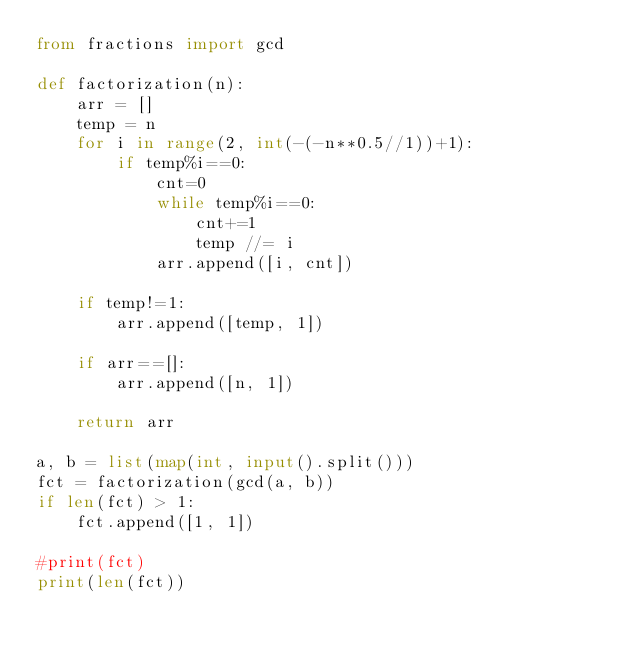Convert code to text. <code><loc_0><loc_0><loc_500><loc_500><_Python_>from fractions import gcd

def factorization(n):
    arr = []
    temp = n
    for i in range(2, int(-(-n**0.5//1))+1):
        if temp%i==0:
            cnt=0
            while temp%i==0:
                cnt+=1
                temp //= i
            arr.append([i, cnt])

    if temp!=1:
        arr.append([temp, 1])

    if arr==[]:
        arr.append([n, 1])

    return arr

a, b = list(map(int, input().split()))
fct = factorization(gcd(a, b))
if len(fct) > 1:
    fct.append([1, 1])

#print(fct)
print(len(fct))</code> 